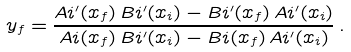<formula> <loc_0><loc_0><loc_500><loc_500>y _ { f } = \frac { A i ^ { \prime } ( x _ { f } ) \, B i ^ { \prime } ( x _ { i } ) - B i ^ { \prime } ( x _ { f } ) \, A i ^ { \prime } ( x _ { i } ) } { A i ( x _ { f } ) \, B i ^ { \prime } ( x _ { i } ) - B i ( x _ { f } ) \, A i ^ { \prime } ( x _ { i } ) } \, .</formula> 